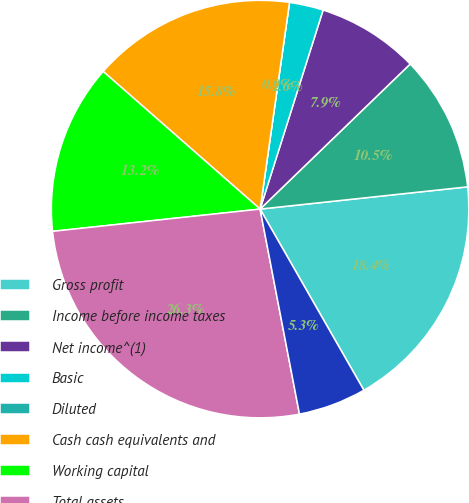Convert chart. <chart><loc_0><loc_0><loc_500><loc_500><pie_chart><fcel>Gross profit<fcel>Income before income taxes<fcel>Net income^(1)<fcel>Basic<fcel>Diluted<fcel>Cash cash equivalents and<fcel>Working capital<fcel>Total assets<fcel>Worldwide employees<nl><fcel>18.42%<fcel>10.53%<fcel>7.89%<fcel>2.63%<fcel>0.0%<fcel>15.79%<fcel>13.16%<fcel>26.32%<fcel>5.26%<nl></chart> 